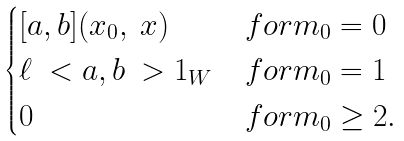Convert formula to latex. <formula><loc_0><loc_0><loc_500><loc_500>\begin{cases} [ a , b ] ( x _ { 0 } , \ x ) & f o r m _ { 0 } = 0 \\ \ell \ < a , b \ > 1 _ { W } & f o r m _ { 0 } = 1 \\ 0 & f o r m _ { 0 } \geq 2 . \end{cases}</formula> 